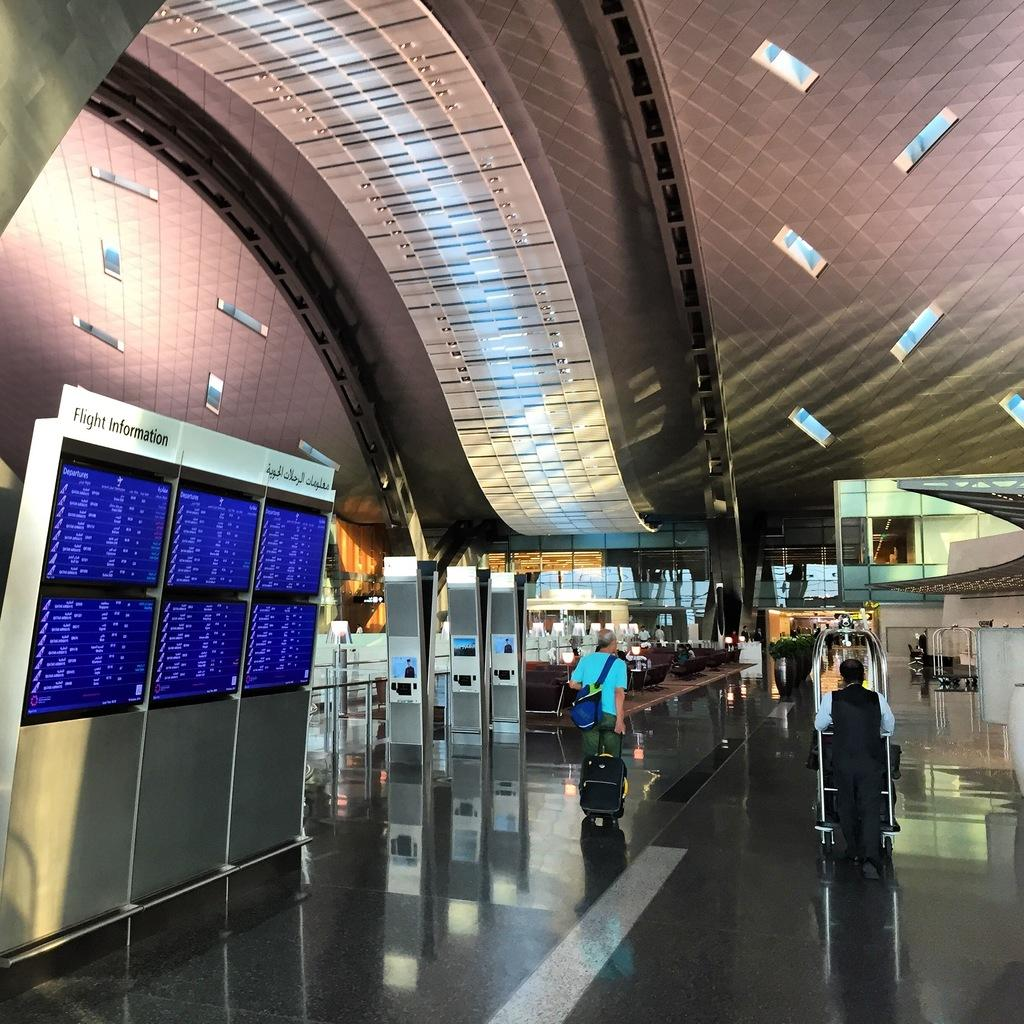What can be seen on the screens in the image? Something is written on the screens in the image. What are the people near the screens doing? There are people standing near the screens in the image. Can you describe the person carrying a bag? One person is carrying a bag in the image. What type of belief can be seen on the screens in the image? There is no mention of beliefs on the screens in the image; they display written content. How many seats are available for the people in the image? The image does not show any seats, so it is impossible to determine the number of available seats. 